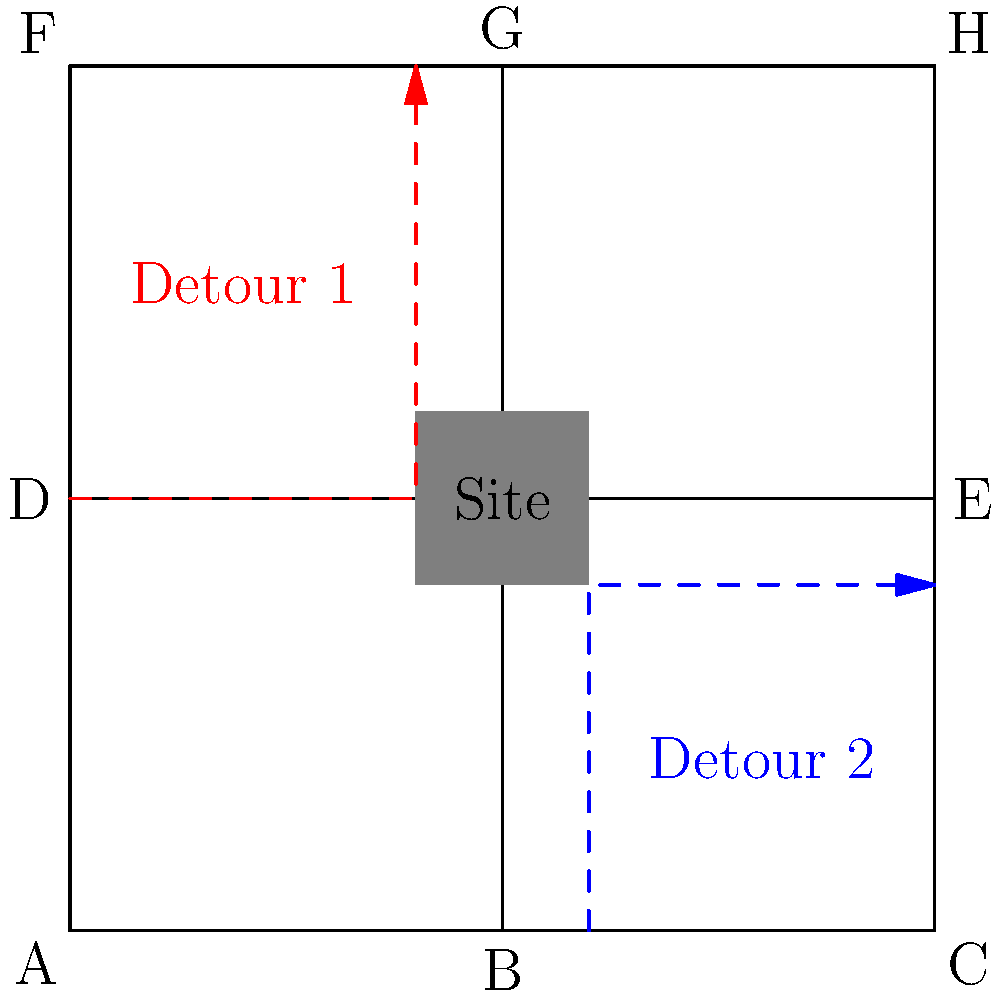Given the street map and proposed detour routes around a construction site, which detour route is likely to cause the least disruption to normal traffic flow? Consider factors such as route length, number of turns, and potential bottlenecks. To analyze which detour route will cause the least disruption, we need to consider several factors:

1. Route length:
   Detour 1: $40 + 50 = 90$ units
   Detour 2: $40 + 40 = 80$ units

2. Number of turns:
   Detour 1: 1 turn (at intersection D)
   Detour 2: 1 turn (at intersection B)

3. Potential bottlenecks:
   Detour 1: Redirects traffic to the northern part of the map, potentially causing congestion at intersections D and G.
   Detour 2: Redirects traffic to the eastern part of the map, potentially causing congestion at intersections B and E.

4. Impact on normal traffic flow:
   Detour 1: Affects north-south traffic on the left side of the map and east-west traffic on the top of the map.
   Detour 2: Affects east-west traffic on the bottom of the map and north-south traffic on the right side of the map.

5. Distribution of traffic:
   Detour 1: Concentrates traffic on two sides of the construction site.
   Detour 2: Distributes traffic more evenly around the construction site.

Considering these factors:
- Detour 2 is shorter by 10 units, which could lead to faster travel times and less overall disruption.
- Both detours have the same number of turns, so this factor doesn't differentiate them.
- Detour 2 appears to distribute traffic more evenly around the construction site, potentially reducing the likelihood of severe bottlenecks.
- Detour 2 affects a smaller portion of the map, potentially causing less overall disruption to normal traffic patterns.

Based on this analysis, Detour 2 is likely to cause the least disruption to normal traffic flow.
Answer: Detour 2 